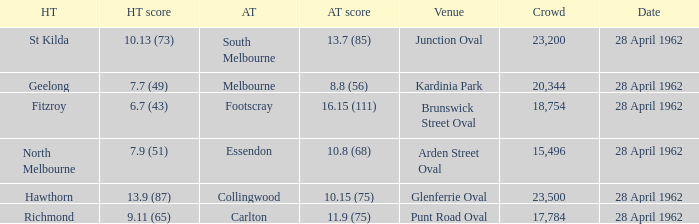At what venue did an away team score 10.15 (75)? Glenferrie Oval. 